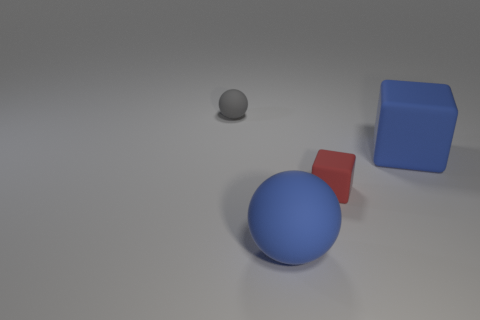What is the material of the other large object that is the same shape as the gray rubber thing?
Provide a short and direct response. Rubber. How many blue things are either big spheres or matte cubes?
Keep it short and to the point. 2. Is there any other thing that is the same color as the large ball?
Keep it short and to the point. Yes. There is a tiny object to the right of the small ball that is left of the small red rubber block; what is its color?
Keep it short and to the point. Red. Are there fewer red rubber objects on the left side of the large blue matte sphere than small rubber blocks that are to the right of the tiny sphere?
Make the answer very short. Yes. There is a big sphere that is the same color as the large cube; what is it made of?
Offer a terse response. Rubber. How many objects are either cubes that are in front of the big cube or large yellow objects?
Offer a very short reply. 1. There is a blue object that is to the left of the red rubber thing; does it have the same size as the small block?
Give a very brief answer. No. Is the number of blue blocks in front of the big blue matte ball less than the number of small red rubber objects?
Offer a very short reply. Yes. What number of tiny objects are brown shiny spheres or blue cubes?
Your answer should be compact. 0. 